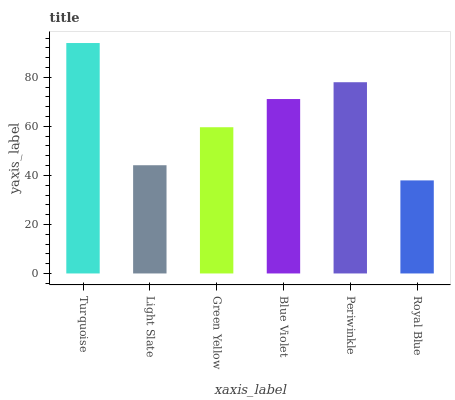Is Royal Blue the minimum?
Answer yes or no. Yes. Is Turquoise the maximum?
Answer yes or no. Yes. Is Light Slate the minimum?
Answer yes or no. No. Is Light Slate the maximum?
Answer yes or no. No. Is Turquoise greater than Light Slate?
Answer yes or no. Yes. Is Light Slate less than Turquoise?
Answer yes or no. Yes. Is Light Slate greater than Turquoise?
Answer yes or no. No. Is Turquoise less than Light Slate?
Answer yes or no. No. Is Blue Violet the high median?
Answer yes or no. Yes. Is Green Yellow the low median?
Answer yes or no. Yes. Is Royal Blue the high median?
Answer yes or no. No. Is Periwinkle the low median?
Answer yes or no. No. 